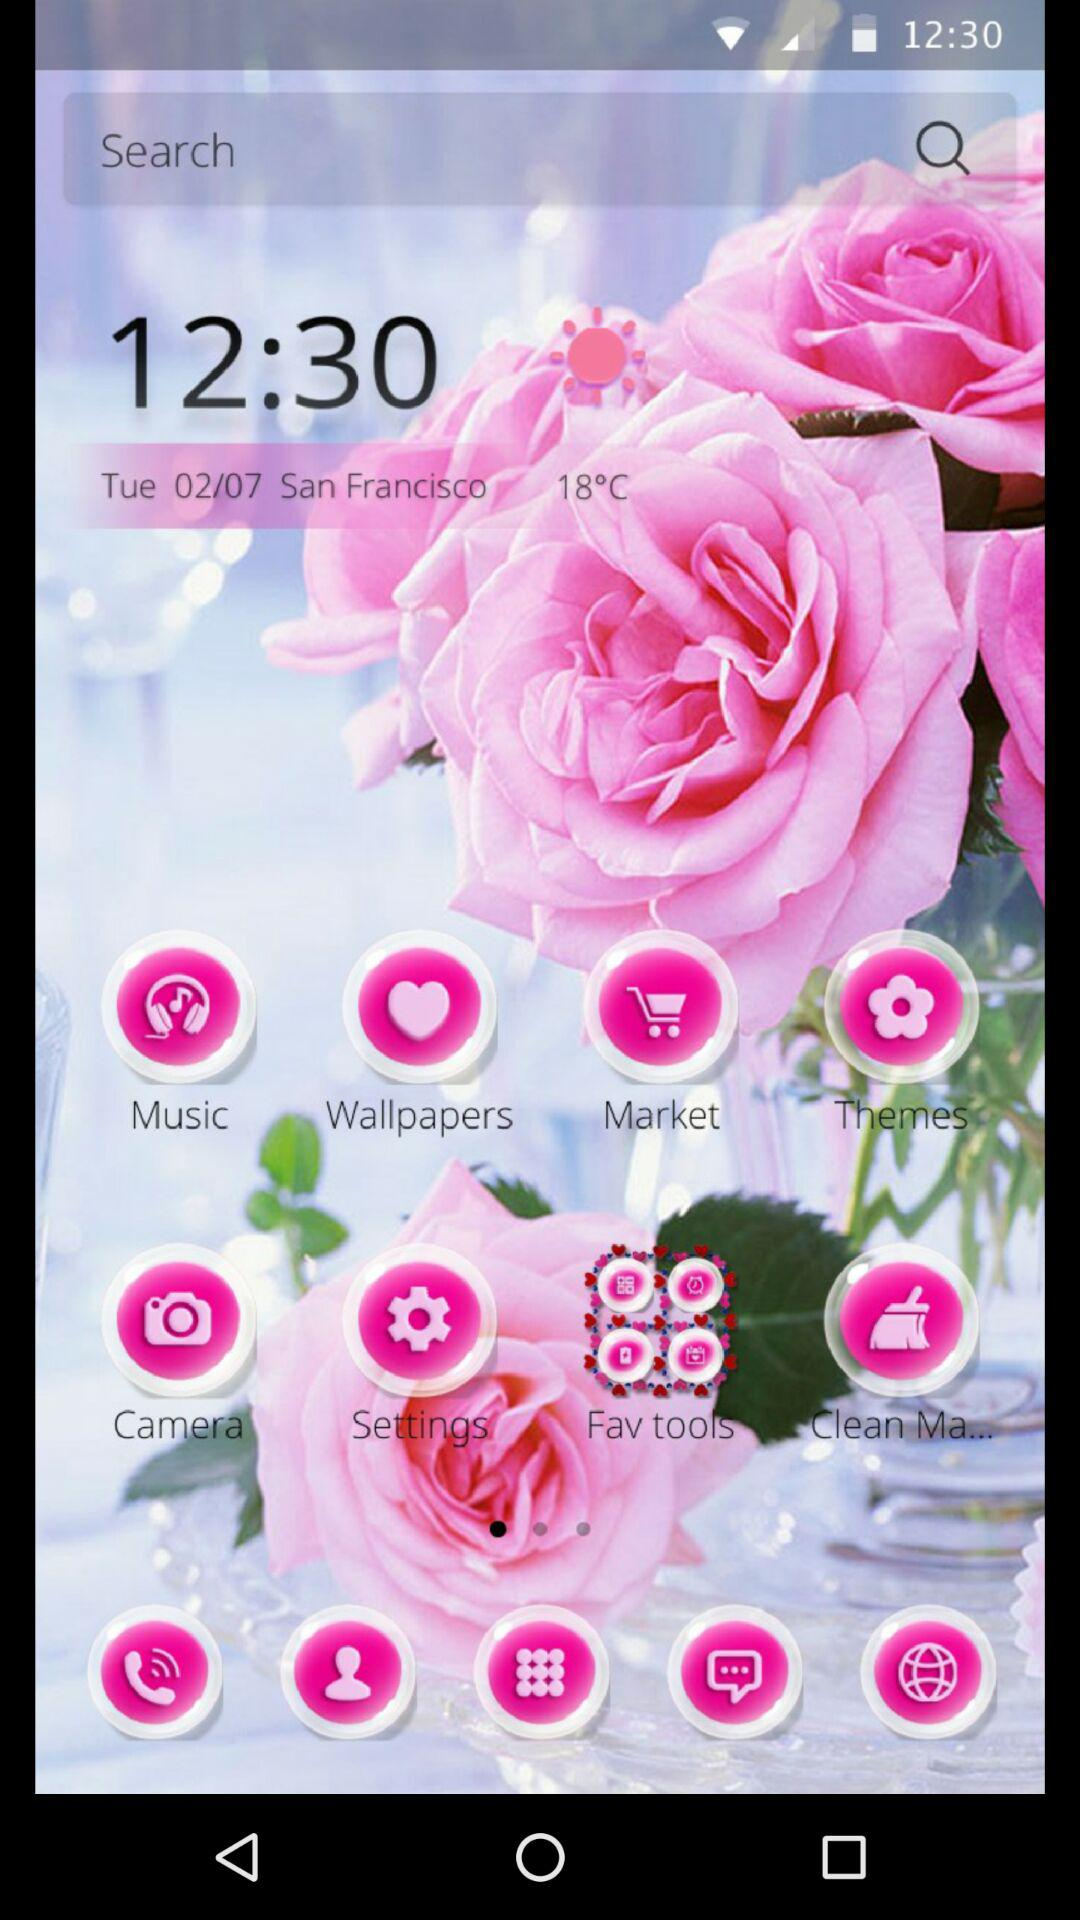What is the time? The time is 12:30. 